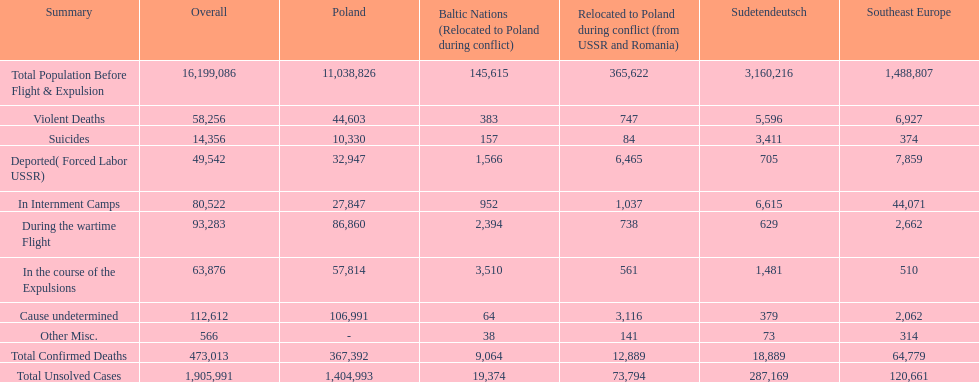What is the difference between suicides in poland and sudetendeutsch? 6919. 